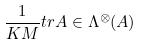Convert formula to latex. <formula><loc_0><loc_0><loc_500><loc_500>\frac { 1 } { K M } t r A \in \Lambda ^ { \otimes } ( A )</formula> 